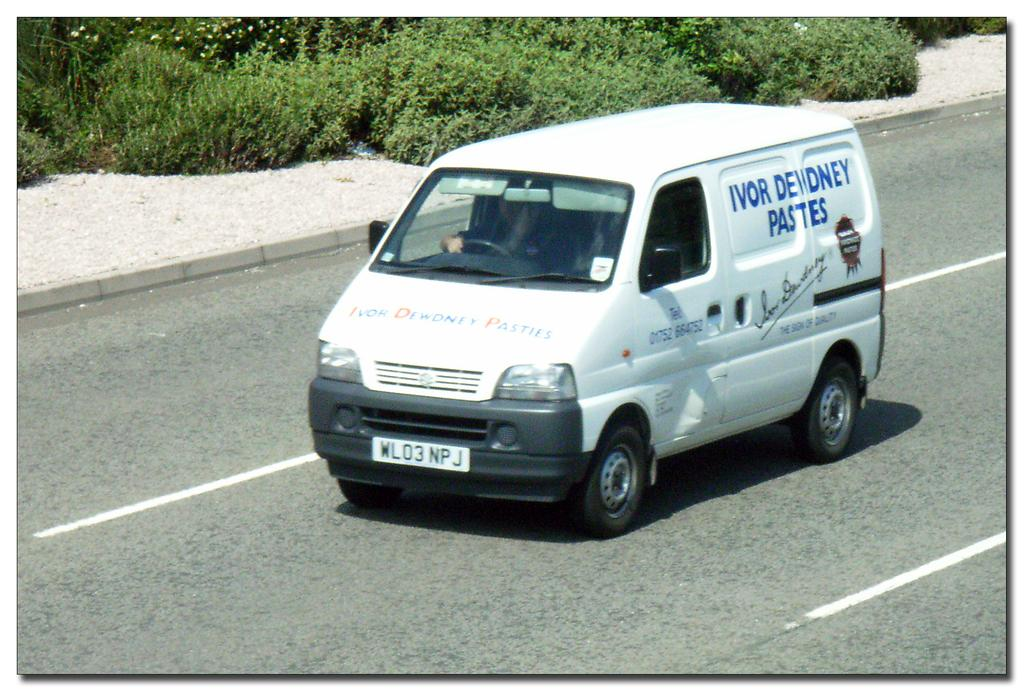What is on the road in the image? There is a vehicle on the road in the image. Who is inside the vehicle? A person is sitting inside the vehicle. What can be seen in the distance in the image? There are trees visible in the background of the image. What type of quilt is being used to cover the train tracks in the image? There is no quilt or train tracks present in the image; it features a vehicle on the road with a person inside and trees in the background. 